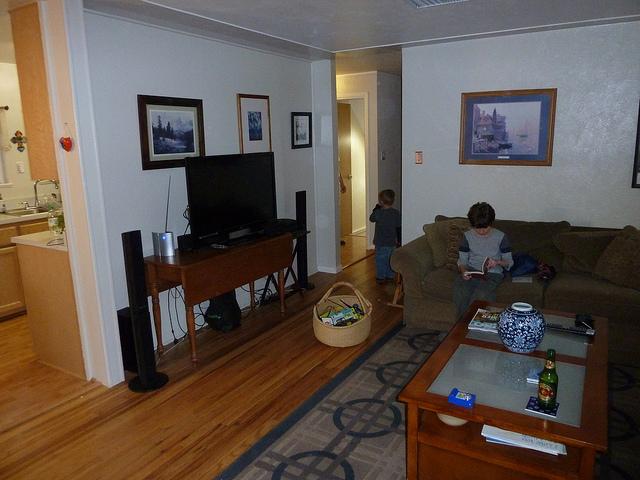What is in the blue vase?
Give a very brief answer. Nothing. What is in the middle of the table?
Concise answer only. Vase. Are there guitars in the picture?
Write a very short answer. No. Is the beer bottle open?
Be succinct. Yes. Is the coffee table reflective?
Quick response, please. Yes. How many rooms are shown?
Write a very short answer. 3. How many pictures are on the wall?
Keep it brief. 4. What Holiday does this picture depict?
Be succinct. Easter. Is the television on?
Answer briefly. No. How many inanimate animals are there in the photo?
Be succinct. 0. What would someone do in this room?
Be succinct. Watch tv. 